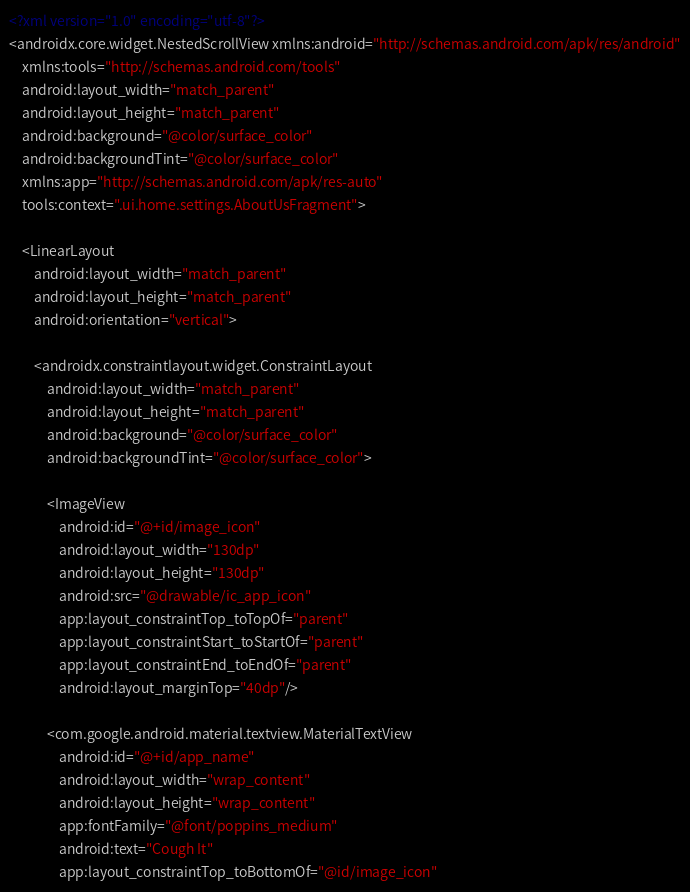Convert code to text. <code><loc_0><loc_0><loc_500><loc_500><_XML_><?xml version="1.0" encoding="utf-8"?>
<androidx.core.widget.NestedScrollView xmlns:android="http://schemas.android.com/apk/res/android"
    xmlns:tools="http://schemas.android.com/tools"
    android:layout_width="match_parent"
    android:layout_height="match_parent"
    android:background="@color/surface_color"
    android:backgroundTint="@color/surface_color"
    xmlns:app="http://schemas.android.com/apk/res-auto"
    tools:context=".ui.home.settings.AboutUsFragment">

    <LinearLayout
        android:layout_width="match_parent"
        android:layout_height="match_parent"
        android:orientation="vertical">

        <androidx.constraintlayout.widget.ConstraintLayout
            android:layout_width="match_parent"
            android:layout_height="match_parent"
            android:background="@color/surface_color"
            android:backgroundTint="@color/surface_color">

            <ImageView
                android:id="@+id/image_icon"
                android:layout_width="130dp"
                android:layout_height="130dp"
                android:src="@drawable/ic_app_icon"
                app:layout_constraintTop_toTopOf="parent"
                app:layout_constraintStart_toStartOf="parent"
                app:layout_constraintEnd_toEndOf="parent"
                android:layout_marginTop="40dp"/>

            <com.google.android.material.textview.MaterialTextView
                android:id="@+id/app_name"
                android:layout_width="wrap_content"
                android:layout_height="wrap_content"
                app:fontFamily="@font/poppins_medium"
                android:text="Cough It"
                app:layout_constraintTop_toBottomOf="@id/image_icon"</code> 